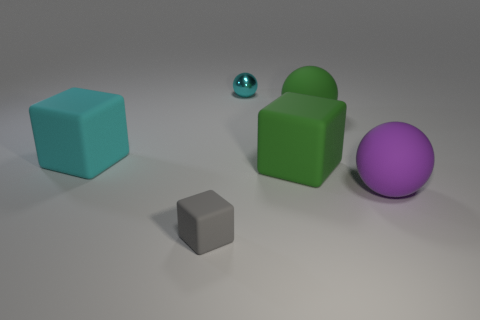Subtract all green matte cubes. How many cubes are left? 2 Add 1 large brown shiny cylinders. How many objects exist? 7 Subtract all purple spheres. How many spheres are left? 2 Subtract all blue cylinders. How many yellow spheres are left? 0 Subtract all big balls. Subtract all tiny metallic objects. How many objects are left? 3 Add 3 big green spheres. How many big green spheres are left? 4 Add 6 tiny gray metal cylinders. How many tiny gray metal cylinders exist? 6 Subtract 0 brown cylinders. How many objects are left? 6 Subtract 1 cubes. How many cubes are left? 2 Subtract all gray spheres. Subtract all red cylinders. How many spheres are left? 3 